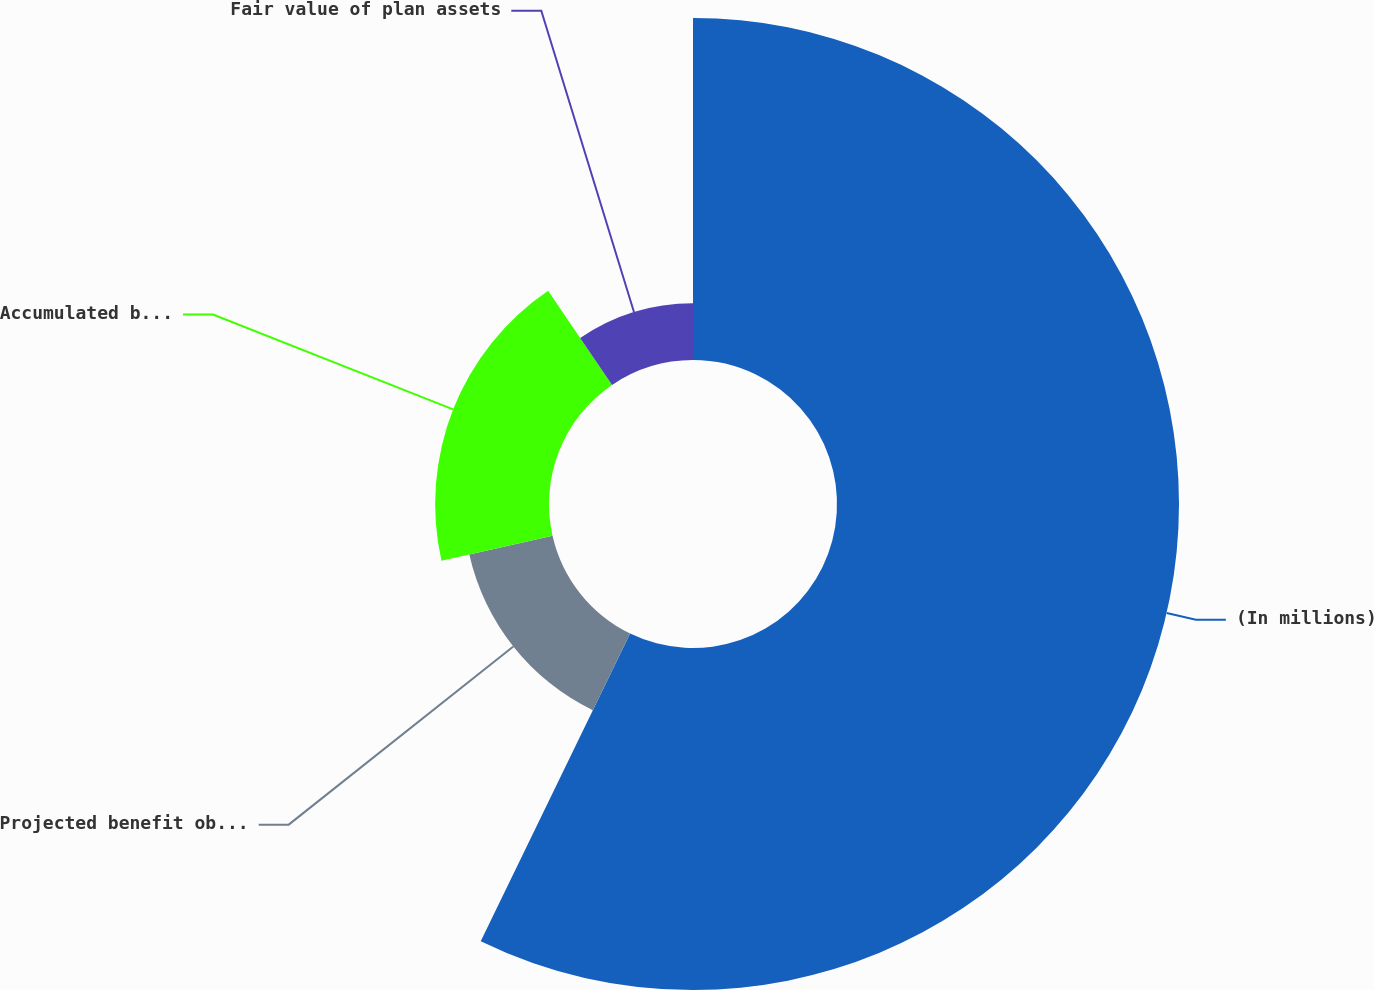Convert chart to OTSL. <chart><loc_0><loc_0><loc_500><loc_500><pie_chart><fcel>(In millions)<fcel>Projected benefit obligation<fcel>Accumulated benefit obligation<fcel>Fair value of plan assets<nl><fcel>57.2%<fcel>14.27%<fcel>19.04%<fcel>9.5%<nl></chart> 